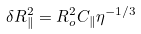<formula> <loc_0><loc_0><loc_500><loc_500>\delta R ^ { 2 } _ { \| } = R _ { o } ^ { 2 } C _ { \| } \eta ^ { - 1 / 3 }</formula> 